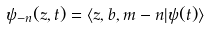Convert formula to latex. <formula><loc_0><loc_0><loc_500><loc_500>\psi _ { - n } ( z , t ) = \langle z , b , m - n | \psi ( t ) \rangle</formula> 